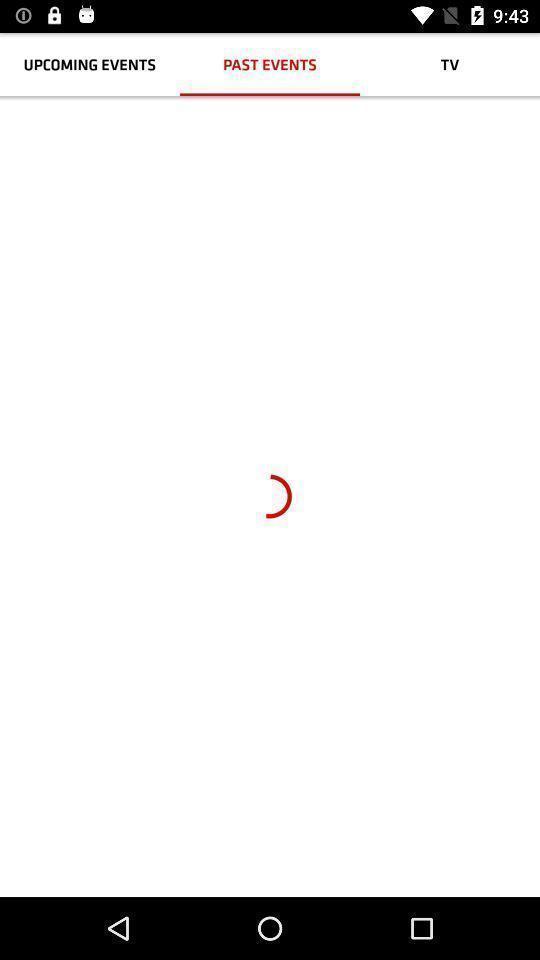Explain what's happening in this screen capture. Screen displaying past events page. 